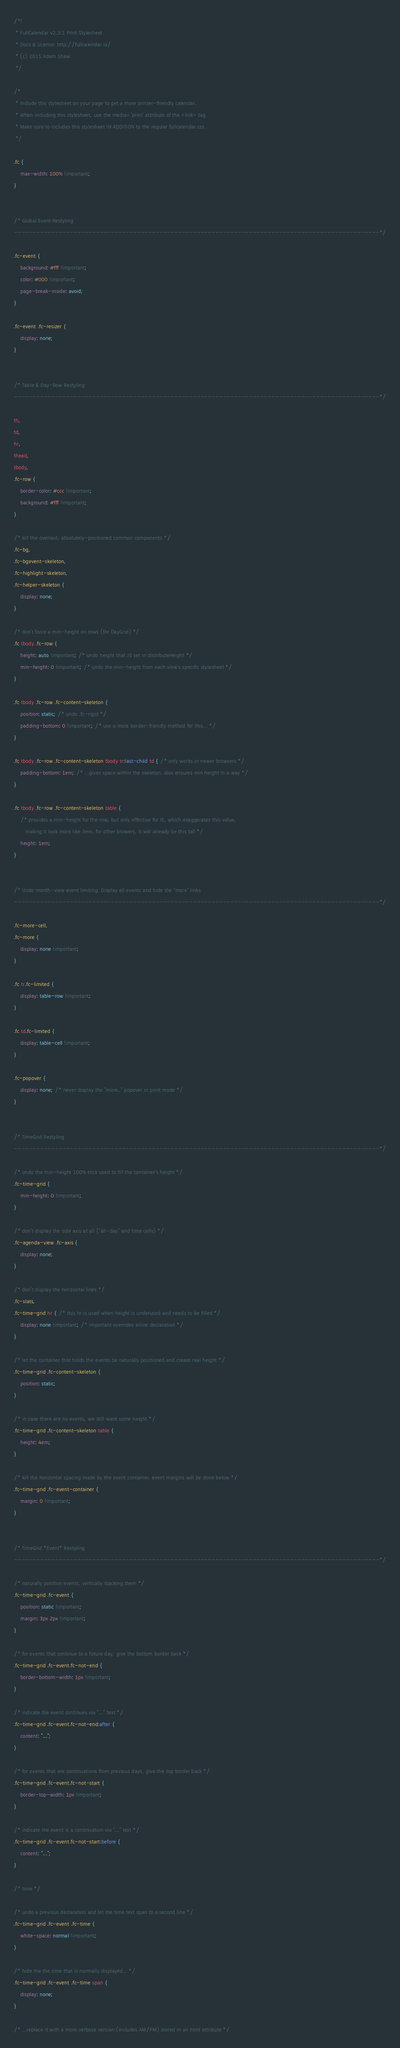Convert code to text. <code><loc_0><loc_0><loc_500><loc_500><_CSS_>/*!
 * FullCalendar v2.3.1 Print Stylesheet
 * Docs & License: http://fullcalendar.io/
 * (c) 2015 Adam Shaw
 */

/*
 * Include this stylesheet on your page to get a more printer-friendly calendar.
 * When including this stylesheet, use the media='print' attribute of the <link> tag.
 * Make sure to includes this stylesheet IN ADDITION to the regular fullcalendar.css.
 */

.fc {
	max-width: 100% !important;
}


/* Global Event Restyling
--------------------------------------------------------------------------------------------------*/

.fc-event {
	background: #fff !important;
	color: #000 !important;
	page-break-inside: avoid;
}

.fc-event .fc-resizer {
	display: none;
}


/* Table & Day-Row Restyling
--------------------------------------------------------------------------------------------------*/

th,
td,
hr,
thead,
tbody,
.fc-row {
	border-color: #ccc !important;
	background: #fff !important;
}

/* kill the overlaid, absolutely-positioned common components */
.fc-bg,
.fc-bgevent-skeleton,
.fc-highlight-skeleton,
.fc-helper-skeleton {
	display: none;
}

/* don't force a min-height on rows (for DayGrid) */
.fc tbody .fc-row {
	height: auto !important; /* undo height that JS set in distributeHeight */
	min-height: 0 !important; /* undo the min-height from each view's specific stylesheet */
}

.fc tbody .fc-row .fc-content-skeleton {
	position: static; /* undo .fc-rigid */
	padding-bottom: 0 !important; /* use a more border-friendly method for this... */
}

.fc tbody .fc-row .fc-content-skeleton tbody tr:last-child td { /* only works in newer browsers */
	padding-bottom: 1em; /* ...gives space within the skeleton. also ensures min height in a way */
}

.fc tbody .fc-row .fc-content-skeleton table {
	/* provides a min-height for the row, but only effective for IE, which exaggerates this value,
	   making it look more like 3em. for other browers, it will already be this tall */
	height: 1em;
}


/* Undo month-view event limiting. Display all events and hide the "more" links
--------------------------------------------------------------------------------------------------*/

.fc-more-cell,
.fc-more {
	display: none !important;
}

.fc tr.fc-limited {
	display: table-row !important;
}

.fc td.fc-limited {
	display: table-cell !important;
}

.fc-popover {
	display: none; /* never display the "more.." popover in print mode */
}


/* TimeGrid Restyling
--------------------------------------------------------------------------------------------------*/

/* undo the min-height 100% trick used to fill the container's height */
.fc-time-grid {
	min-height: 0 !important;
}

/* don't display the side axis at all ("all-day" and time cells) */
.fc-agenda-view .fc-axis {
	display: none;
}

/* don't display the horizontal lines */
.fc-slats,
.fc-time-grid hr { /* this hr is used when height is underused and needs to be filled */
	display: none !important; /* important overrides inline declaration */
}

/* let the container that holds the events be naturally positioned and create real height */
.fc-time-grid .fc-content-skeleton {
	position: static;
}

/* in case there are no events, we still want some height */
.fc-time-grid .fc-content-skeleton table {
	height: 4em;
}

/* kill the horizontal spacing made by the event container. event margins will be done below */
.fc-time-grid .fc-event-container {
	margin: 0 !important;
}


/* TimeGrid *Event* Restyling
--------------------------------------------------------------------------------------------------*/

/* naturally position events, vertically stacking them */
.fc-time-grid .fc-event {
	position: static !important;
	margin: 3px 2px !important;
}

/* for events that continue to a future day, give the bottom border back */
.fc-time-grid .fc-event.fc-not-end {
	border-bottom-width: 1px !important;
}

/* indicate the event continues via "..." text */
.fc-time-grid .fc-event.fc-not-end:after {
	content: "...";
}

/* for events that are continuations from previous days, give the top border back */
.fc-time-grid .fc-event.fc-not-start {
	border-top-width: 1px !important;
}

/* indicate the event is a continuation via "..." text */
.fc-time-grid .fc-event.fc-not-start:before {
	content: "...";
}

/* time */

/* undo a previous declaration and let the time text span to a second line */
.fc-time-grid .fc-event .fc-time {
	white-space: normal !important;
}

/* hide the the time that is normally displayed... */
.fc-time-grid .fc-event .fc-time span {
	display: none;
}

/* ...replace it with a more verbose version (includes AM/PM) stored in an html attribute */</code> 